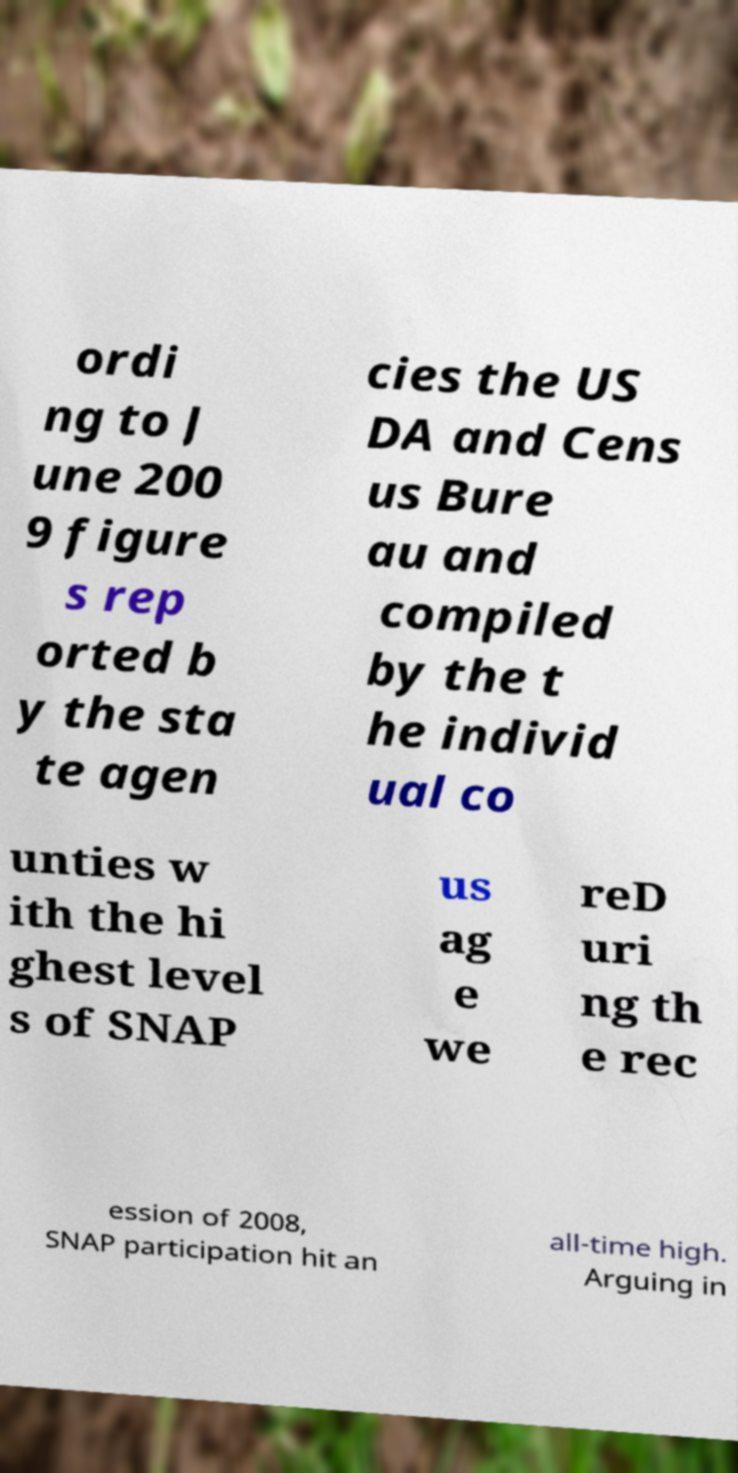Can you accurately transcribe the text from the provided image for me? ordi ng to J une 200 9 figure s rep orted b y the sta te agen cies the US DA and Cens us Bure au and compiled by the t he individ ual co unties w ith the hi ghest level s of SNAP us ag e we reD uri ng th e rec ession of 2008, SNAP participation hit an all-time high. Arguing in 